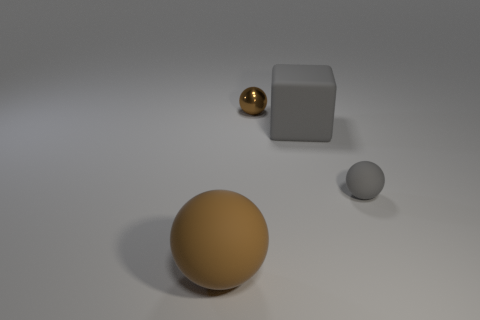Subtract all tiny spheres. How many spheres are left? 1 Subtract all brown cylinders. How many brown balls are left? 2 Add 3 tiny balls. How many objects exist? 7 Subtract all gray balls. How many balls are left? 2 Subtract all spheres. How many objects are left? 1 Add 2 small gray things. How many small gray things are left? 3 Add 4 matte things. How many matte things exist? 7 Subtract 1 gray spheres. How many objects are left? 3 Subtract all cyan balls. Subtract all green cubes. How many balls are left? 3 Subtract all small cyan rubber blocks. Subtract all tiny balls. How many objects are left? 2 